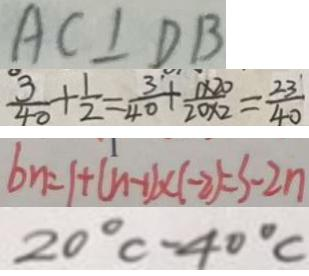<formula> <loc_0><loc_0><loc_500><loc_500>A C \bot D B 
 \frac { 3 } { 4 0 } + \frac { 1 } { 2 } = \frac { 3 } { 4 0 } + \frac { 1 \times 2 0 } { 2 0 \times 2 } = \frac { 2 3 } { 4 0 } 
 b n = 1 + ( n - 1 ) \times ( - 2 ) = 3 - 2 n 
 2 0 ^ { \circ } C - 4 0 ^ { \circ } C</formula> 